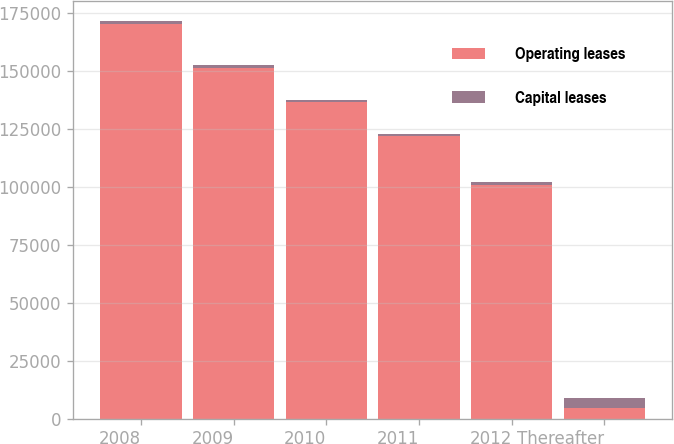Convert chart. <chart><loc_0><loc_0><loc_500><loc_500><stacked_bar_chart><ecel><fcel>2008<fcel>2009<fcel>2010<fcel>2011<fcel>2012<fcel>Thereafter<nl><fcel>Operating leases<fcel>170192<fcel>151344<fcel>136480<fcel>121913<fcel>101035<fcel>4452<nl><fcel>Capital leases<fcel>1579<fcel>1162<fcel>962<fcel>966<fcel>987<fcel>4452<nl></chart> 